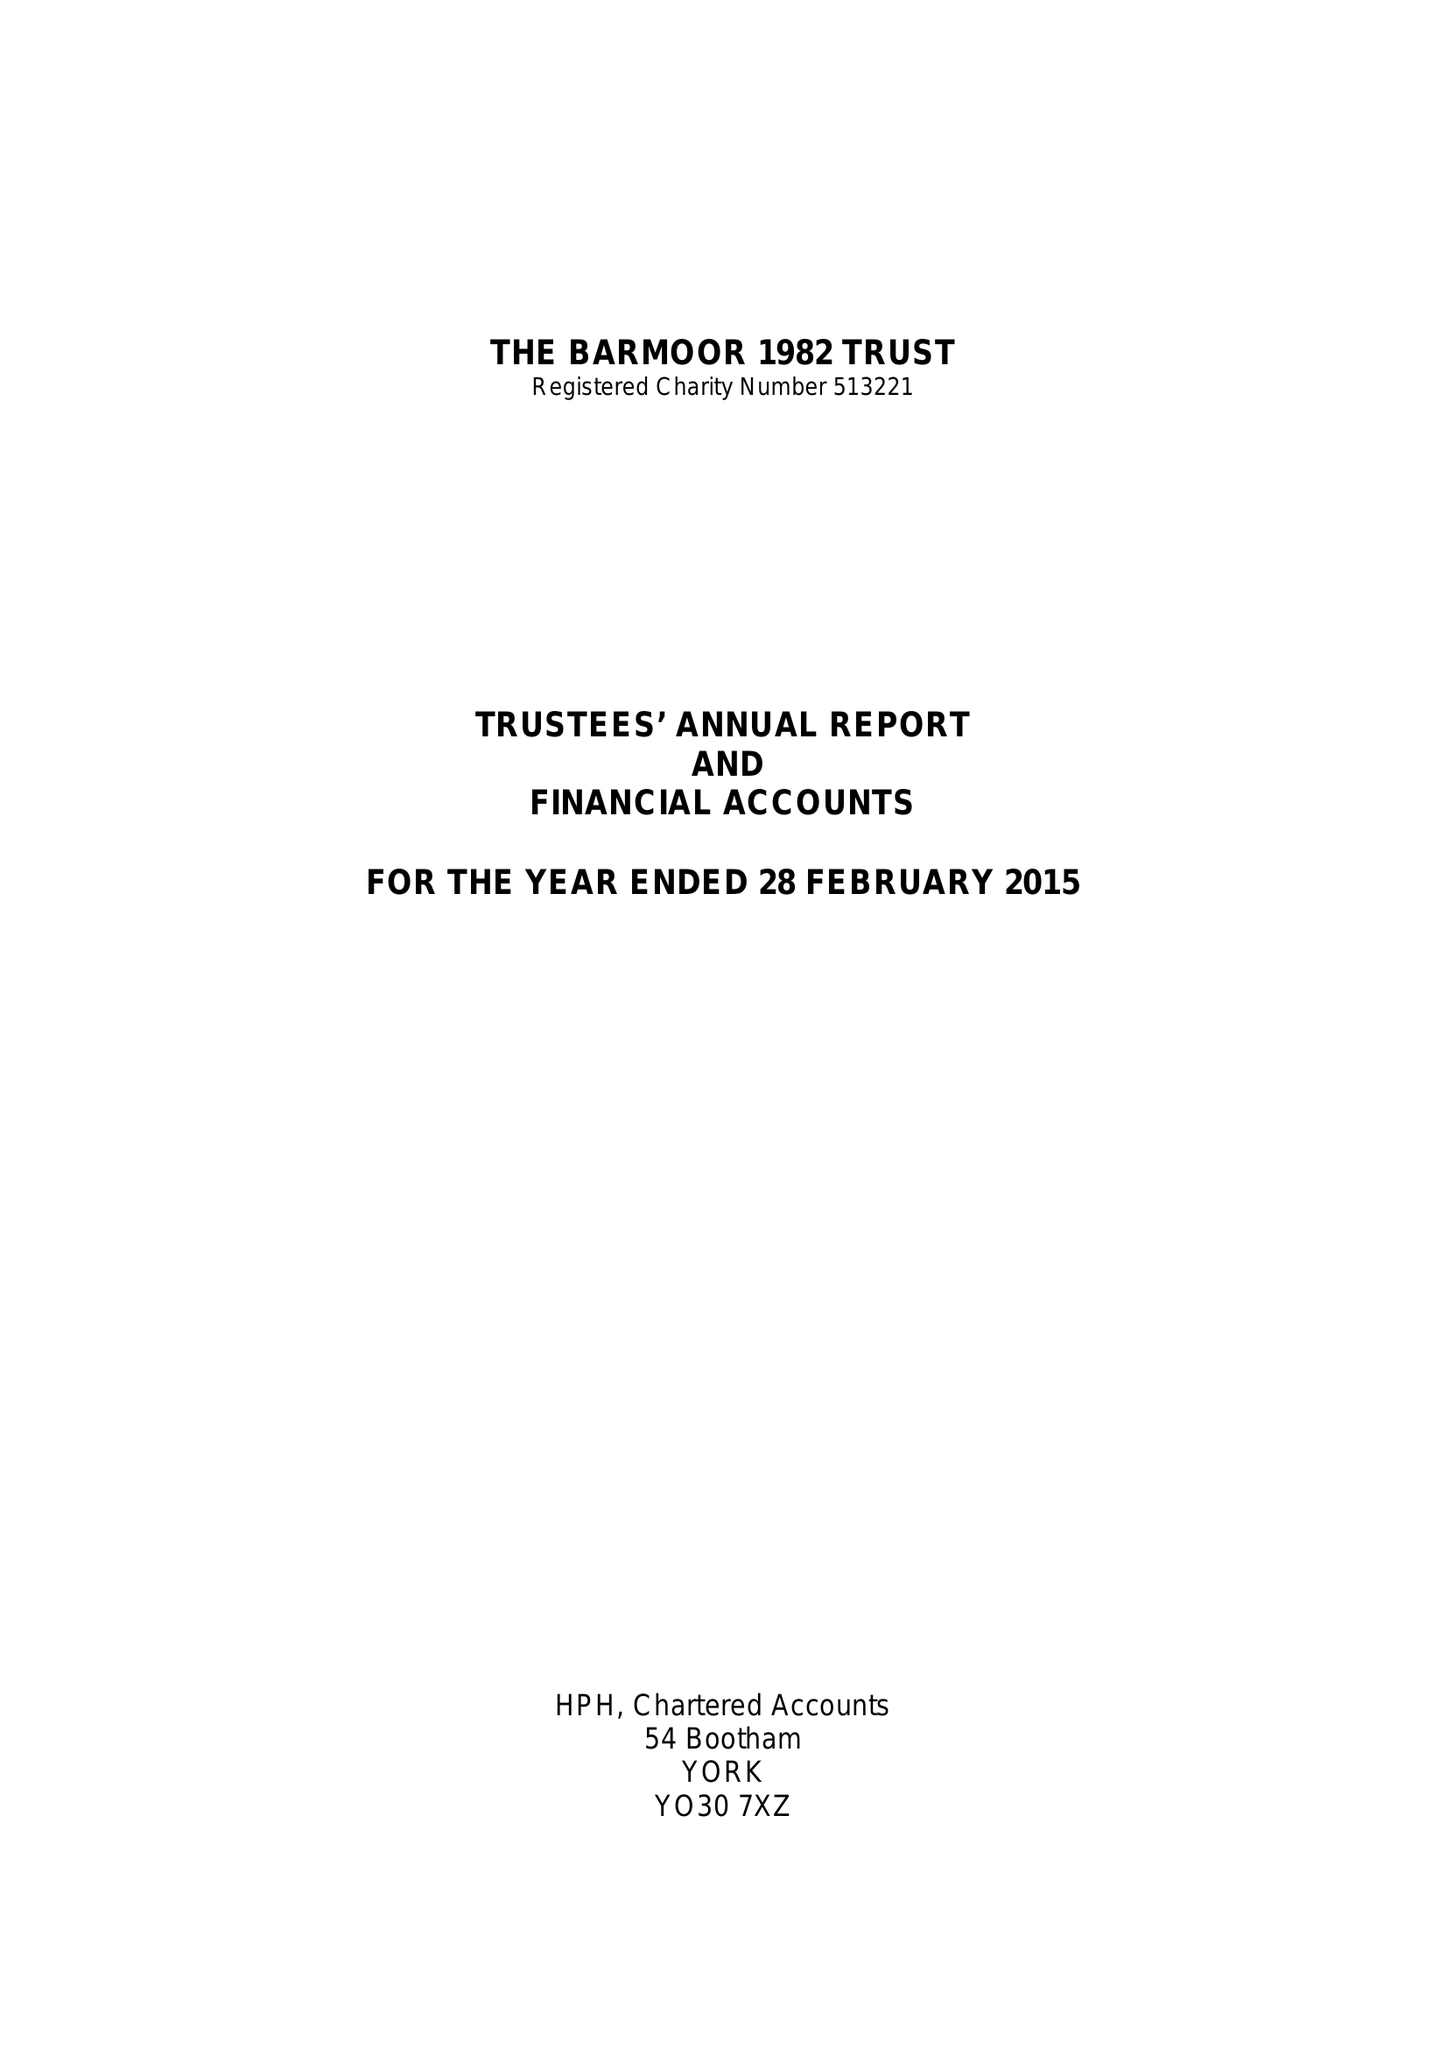What is the value for the spending_annually_in_british_pounds?
Answer the question using a single word or phrase. 64955.26 